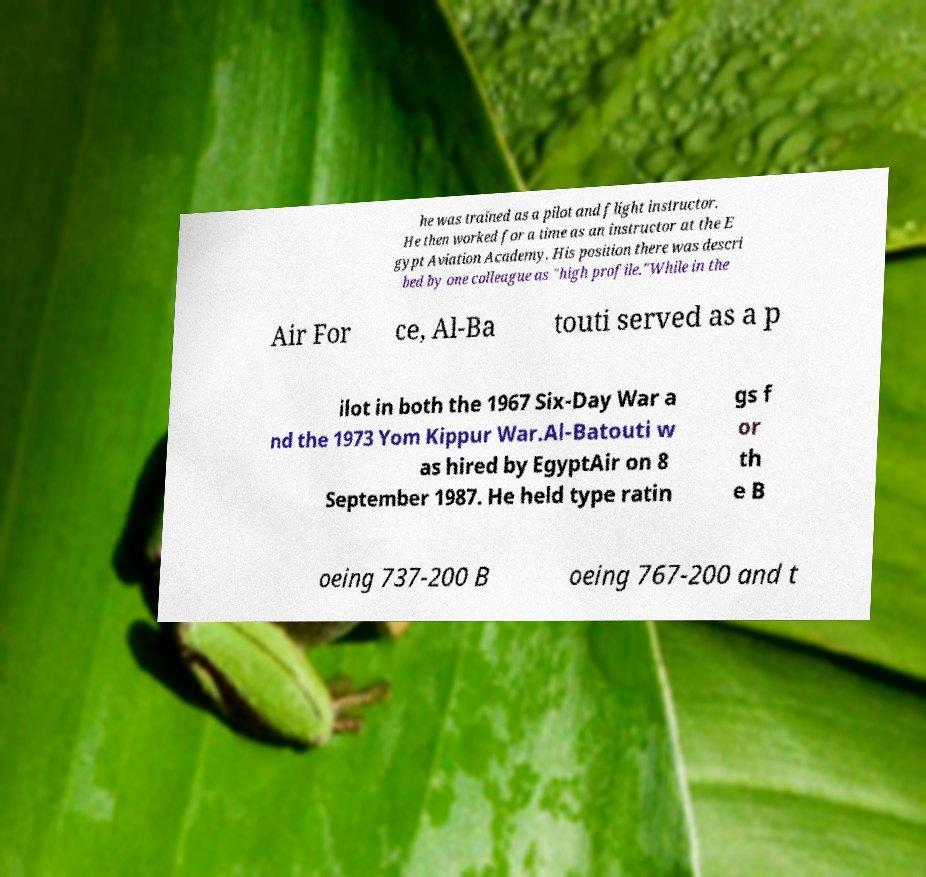For documentation purposes, I need the text within this image transcribed. Could you provide that? he was trained as a pilot and flight instructor. He then worked for a time as an instructor at the E gypt Aviation Academy. His position there was descri bed by one colleague as "high profile."While in the Air For ce, Al-Ba touti served as a p ilot in both the 1967 Six-Day War a nd the 1973 Yom Kippur War.Al-Batouti w as hired by EgyptAir on 8 September 1987. He held type ratin gs f or th e B oeing 737-200 B oeing 767-200 and t 